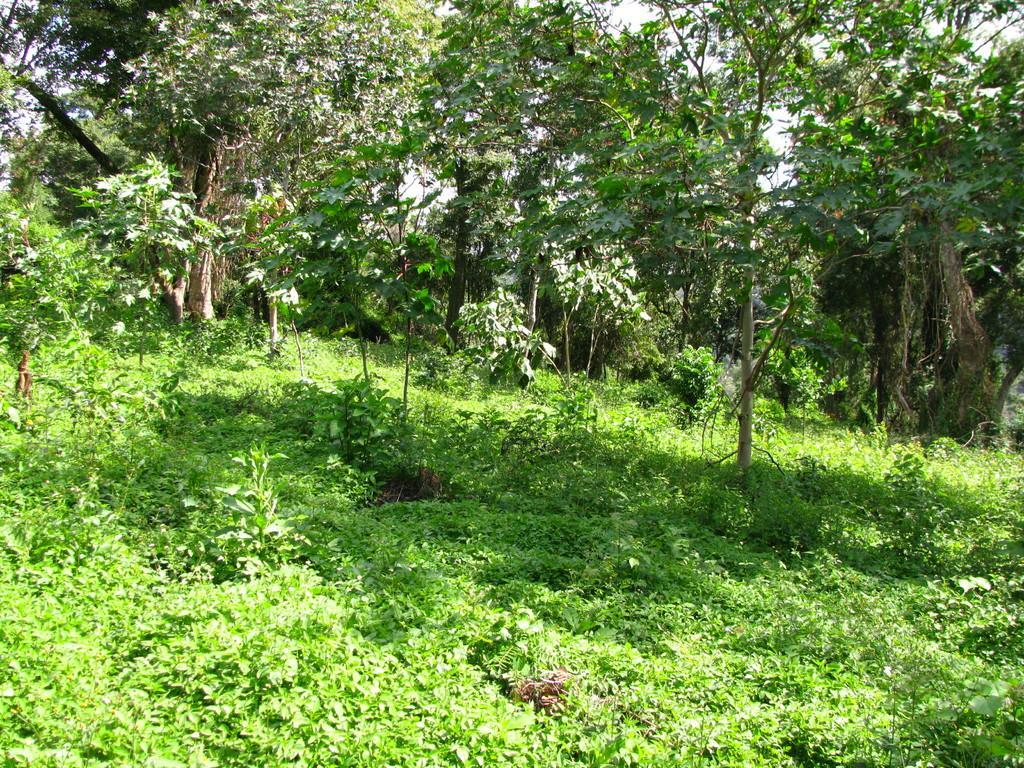Please provide a concise description of this image. In this image there are trees, there are trees truncated towards the right of the image, there is the sky, there are trees truncated towards the left of the image, there are plants, there are plants truncated towards the right of the image, there are plants truncated towards the left of the image. 